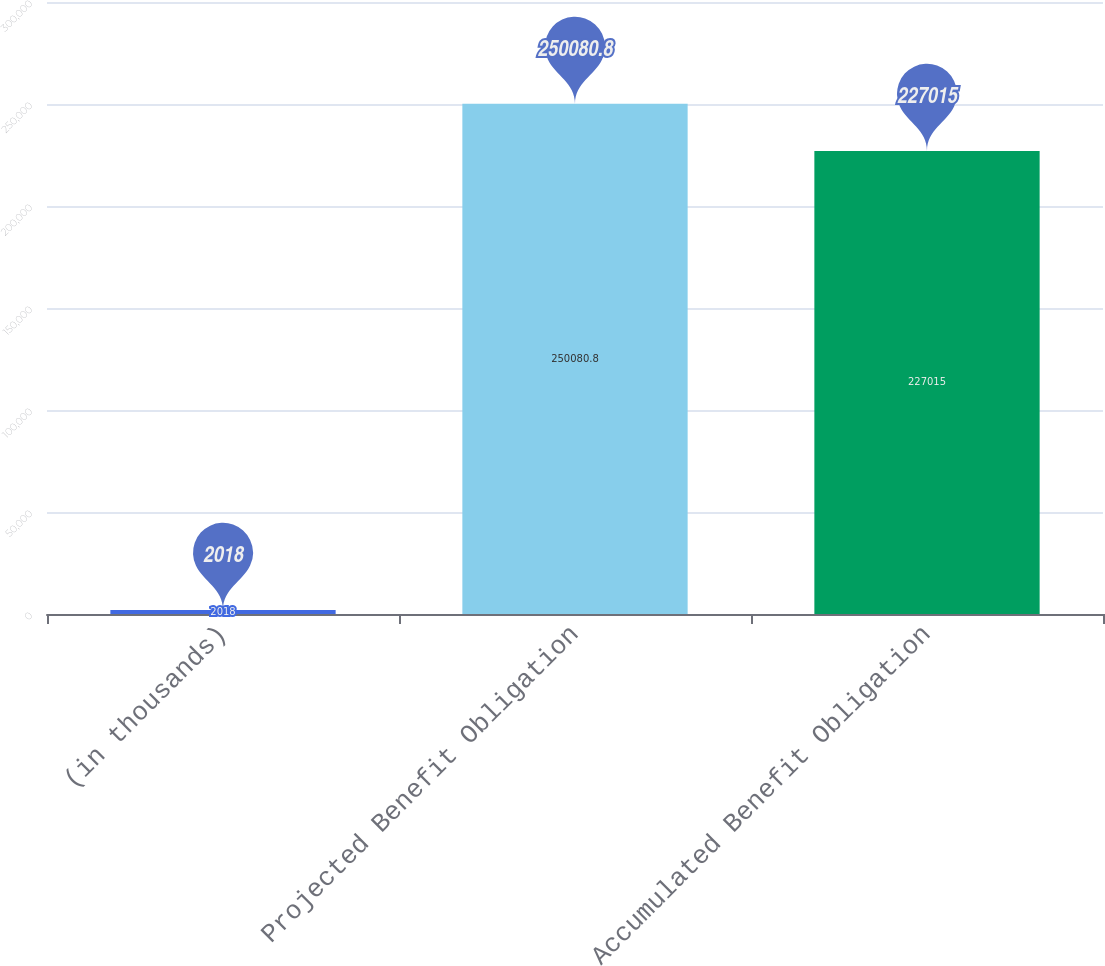Convert chart to OTSL. <chart><loc_0><loc_0><loc_500><loc_500><bar_chart><fcel>(in thousands)<fcel>Projected Benefit Obligation<fcel>Accumulated Benefit Obligation<nl><fcel>2018<fcel>250081<fcel>227015<nl></chart> 